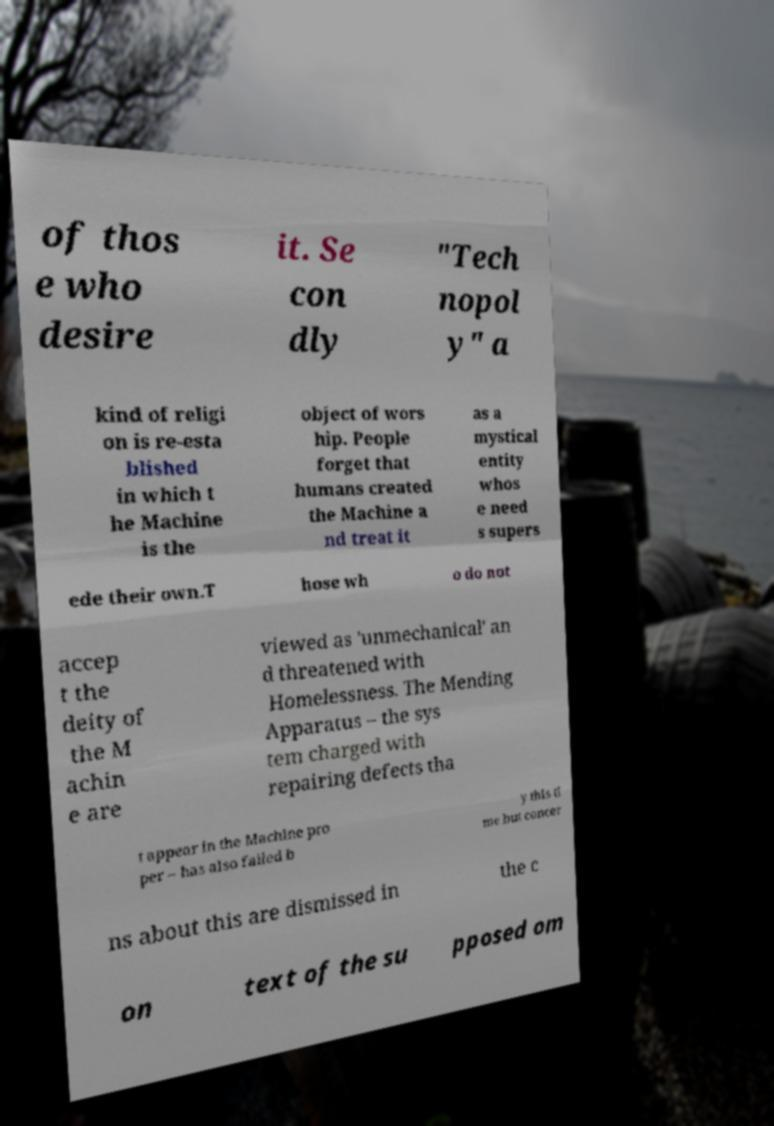Could you extract and type out the text from this image? of thos e who desire it. Se con dly "Tech nopol y" a kind of religi on is re-esta blished in which t he Machine is the object of wors hip. People forget that humans created the Machine a nd treat it as a mystical entity whos e need s supers ede their own.T hose wh o do not accep t the deity of the M achin e are viewed as 'unmechanical' an d threatened with Homelessness. The Mending Apparatus – the sys tem charged with repairing defects tha t appear in the Machine pro per – has also failed b y this ti me but concer ns about this are dismissed in the c on text of the su pposed om 